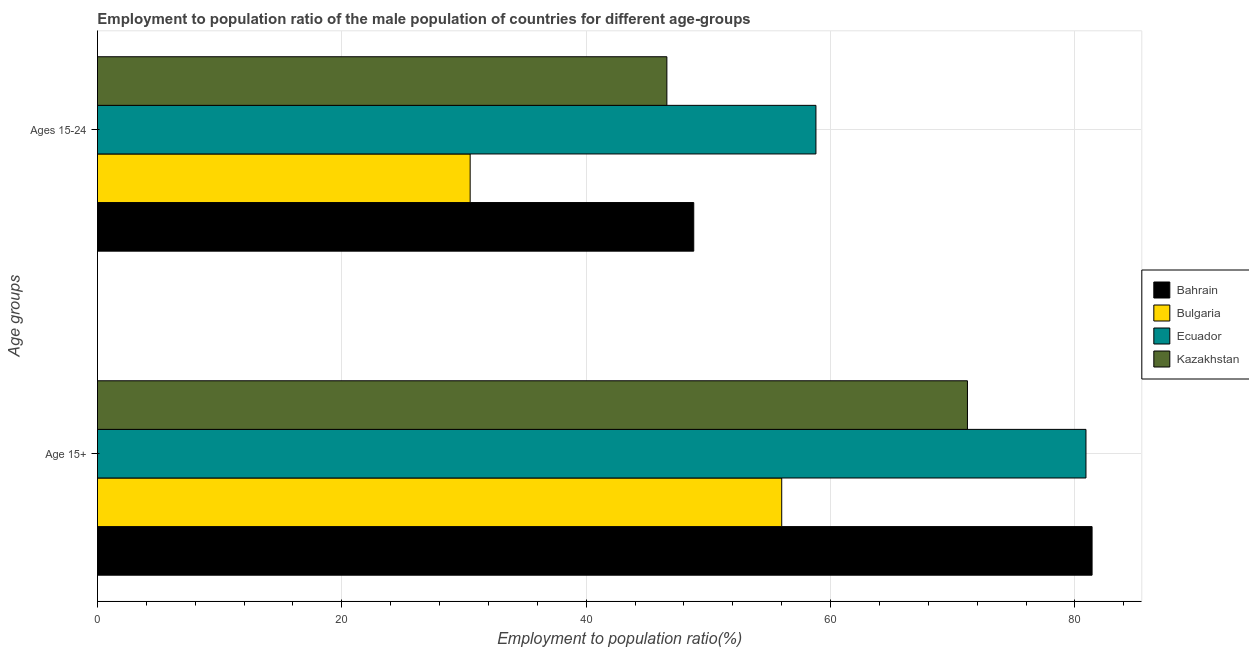How many different coloured bars are there?
Your answer should be compact. 4. How many groups of bars are there?
Offer a very short reply. 2. Are the number of bars per tick equal to the number of legend labels?
Provide a succinct answer. Yes. How many bars are there on the 1st tick from the top?
Provide a succinct answer. 4. What is the label of the 1st group of bars from the top?
Provide a succinct answer. Ages 15-24. What is the employment to population ratio(age 15-24) in Ecuador?
Offer a very short reply. 58.8. Across all countries, what is the maximum employment to population ratio(age 15+)?
Keep it short and to the point. 81.4. Across all countries, what is the minimum employment to population ratio(age 15+)?
Your answer should be compact. 56. In which country was the employment to population ratio(age 15-24) maximum?
Provide a succinct answer. Ecuador. In which country was the employment to population ratio(age 15+) minimum?
Keep it short and to the point. Bulgaria. What is the total employment to population ratio(age 15+) in the graph?
Provide a short and direct response. 289.5. What is the difference between the employment to population ratio(age 15+) in Bahrain and that in Kazakhstan?
Offer a terse response. 10.2. What is the difference between the employment to population ratio(age 15-24) in Bulgaria and the employment to population ratio(age 15+) in Kazakhstan?
Provide a succinct answer. -40.7. What is the average employment to population ratio(age 15-24) per country?
Offer a terse response. 46.17. In how many countries, is the employment to population ratio(age 15-24) greater than 4 %?
Your answer should be compact. 4. What is the ratio of the employment to population ratio(age 15-24) in Bahrain to that in Bulgaria?
Provide a short and direct response. 1.6. Is the employment to population ratio(age 15-24) in Kazakhstan less than that in Ecuador?
Your answer should be compact. Yes. In how many countries, is the employment to population ratio(age 15-24) greater than the average employment to population ratio(age 15-24) taken over all countries?
Offer a very short reply. 3. What does the 3rd bar from the top in Ages 15-24 represents?
Offer a very short reply. Bulgaria. What does the 3rd bar from the bottom in Ages 15-24 represents?
Offer a very short reply. Ecuador. How many bars are there?
Provide a short and direct response. 8. Are all the bars in the graph horizontal?
Keep it short and to the point. Yes. What is the difference between two consecutive major ticks on the X-axis?
Offer a very short reply. 20. Does the graph contain any zero values?
Offer a very short reply. No. Does the graph contain grids?
Provide a succinct answer. Yes. Where does the legend appear in the graph?
Provide a succinct answer. Center right. How many legend labels are there?
Your response must be concise. 4. What is the title of the graph?
Give a very brief answer. Employment to population ratio of the male population of countries for different age-groups. What is the label or title of the X-axis?
Ensure brevity in your answer.  Employment to population ratio(%). What is the label or title of the Y-axis?
Offer a very short reply. Age groups. What is the Employment to population ratio(%) of Bahrain in Age 15+?
Offer a terse response. 81.4. What is the Employment to population ratio(%) in Bulgaria in Age 15+?
Ensure brevity in your answer.  56. What is the Employment to population ratio(%) in Ecuador in Age 15+?
Ensure brevity in your answer.  80.9. What is the Employment to population ratio(%) of Kazakhstan in Age 15+?
Your answer should be compact. 71.2. What is the Employment to population ratio(%) in Bahrain in Ages 15-24?
Offer a terse response. 48.8. What is the Employment to population ratio(%) of Bulgaria in Ages 15-24?
Give a very brief answer. 30.5. What is the Employment to population ratio(%) of Ecuador in Ages 15-24?
Provide a succinct answer. 58.8. What is the Employment to population ratio(%) in Kazakhstan in Ages 15-24?
Provide a short and direct response. 46.6. Across all Age groups, what is the maximum Employment to population ratio(%) of Bahrain?
Make the answer very short. 81.4. Across all Age groups, what is the maximum Employment to population ratio(%) in Bulgaria?
Give a very brief answer. 56. Across all Age groups, what is the maximum Employment to population ratio(%) in Ecuador?
Your answer should be very brief. 80.9. Across all Age groups, what is the maximum Employment to population ratio(%) in Kazakhstan?
Provide a succinct answer. 71.2. Across all Age groups, what is the minimum Employment to population ratio(%) in Bahrain?
Make the answer very short. 48.8. Across all Age groups, what is the minimum Employment to population ratio(%) in Bulgaria?
Keep it short and to the point. 30.5. Across all Age groups, what is the minimum Employment to population ratio(%) in Ecuador?
Your response must be concise. 58.8. Across all Age groups, what is the minimum Employment to population ratio(%) of Kazakhstan?
Provide a succinct answer. 46.6. What is the total Employment to population ratio(%) in Bahrain in the graph?
Offer a very short reply. 130.2. What is the total Employment to population ratio(%) in Bulgaria in the graph?
Keep it short and to the point. 86.5. What is the total Employment to population ratio(%) of Ecuador in the graph?
Your response must be concise. 139.7. What is the total Employment to population ratio(%) in Kazakhstan in the graph?
Your answer should be very brief. 117.8. What is the difference between the Employment to population ratio(%) in Bahrain in Age 15+ and that in Ages 15-24?
Ensure brevity in your answer.  32.6. What is the difference between the Employment to population ratio(%) in Ecuador in Age 15+ and that in Ages 15-24?
Give a very brief answer. 22.1. What is the difference between the Employment to population ratio(%) of Kazakhstan in Age 15+ and that in Ages 15-24?
Provide a succinct answer. 24.6. What is the difference between the Employment to population ratio(%) of Bahrain in Age 15+ and the Employment to population ratio(%) of Bulgaria in Ages 15-24?
Make the answer very short. 50.9. What is the difference between the Employment to population ratio(%) of Bahrain in Age 15+ and the Employment to population ratio(%) of Ecuador in Ages 15-24?
Provide a succinct answer. 22.6. What is the difference between the Employment to population ratio(%) in Bahrain in Age 15+ and the Employment to population ratio(%) in Kazakhstan in Ages 15-24?
Your answer should be very brief. 34.8. What is the difference between the Employment to population ratio(%) of Bulgaria in Age 15+ and the Employment to population ratio(%) of Ecuador in Ages 15-24?
Ensure brevity in your answer.  -2.8. What is the difference between the Employment to population ratio(%) in Ecuador in Age 15+ and the Employment to population ratio(%) in Kazakhstan in Ages 15-24?
Offer a very short reply. 34.3. What is the average Employment to population ratio(%) in Bahrain per Age groups?
Offer a terse response. 65.1. What is the average Employment to population ratio(%) of Bulgaria per Age groups?
Your response must be concise. 43.25. What is the average Employment to population ratio(%) of Ecuador per Age groups?
Make the answer very short. 69.85. What is the average Employment to population ratio(%) of Kazakhstan per Age groups?
Your response must be concise. 58.9. What is the difference between the Employment to population ratio(%) of Bahrain and Employment to population ratio(%) of Bulgaria in Age 15+?
Offer a very short reply. 25.4. What is the difference between the Employment to population ratio(%) in Bahrain and Employment to population ratio(%) in Kazakhstan in Age 15+?
Keep it short and to the point. 10.2. What is the difference between the Employment to population ratio(%) of Bulgaria and Employment to population ratio(%) of Ecuador in Age 15+?
Provide a succinct answer. -24.9. What is the difference between the Employment to population ratio(%) of Bulgaria and Employment to population ratio(%) of Kazakhstan in Age 15+?
Provide a short and direct response. -15.2. What is the difference between the Employment to population ratio(%) of Ecuador and Employment to population ratio(%) of Kazakhstan in Age 15+?
Offer a terse response. 9.7. What is the difference between the Employment to population ratio(%) of Bahrain and Employment to population ratio(%) of Bulgaria in Ages 15-24?
Your answer should be very brief. 18.3. What is the difference between the Employment to population ratio(%) in Bulgaria and Employment to population ratio(%) in Ecuador in Ages 15-24?
Your answer should be compact. -28.3. What is the difference between the Employment to population ratio(%) in Bulgaria and Employment to population ratio(%) in Kazakhstan in Ages 15-24?
Make the answer very short. -16.1. What is the ratio of the Employment to population ratio(%) in Bahrain in Age 15+ to that in Ages 15-24?
Offer a terse response. 1.67. What is the ratio of the Employment to population ratio(%) in Bulgaria in Age 15+ to that in Ages 15-24?
Your response must be concise. 1.84. What is the ratio of the Employment to population ratio(%) in Ecuador in Age 15+ to that in Ages 15-24?
Your answer should be compact. 1.38. What is the ratio of the Employment to population ratio(%) in Kazakhstan in Age 15+ to that in Ages 15-24?
Provide a short and direct response. 1.53. What is the difference between the highest and the second highest Employment to population ratio(%) of Bahrain?
Provide a short and direct response. 32.6. What is the difference between the highest and the second highest Employment to population ratio(%) of Bulgaria?
Your answer should be compact. 25.5. What is the difference between the highest and the second highest Employment to population ratio(%) in Ecuador?
Give a very brief answer. 22.1. What is the difference between the highest and the second highest Employment to population ratio(%) in Kazakhstan?
Ensure brevity in your answer.  24.6. What is the difference between the highest and the lowest Employment to population ratio(%) in Bahrain?
Your answer should be very brief. 32.6. What is the difference between the highest and the lowest Employment to population ratio(%) of Ecuador?
Your response must be concise. 22.1. What is the difference between the highest and the lowest Employment to population ratio(%) in Kazakhstan?
Offer a terse response. 24.6. 